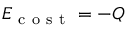<formula> <loc_0><loc_0><loc_500><loc_500>E _ { c o s t } = - Q</formula> 